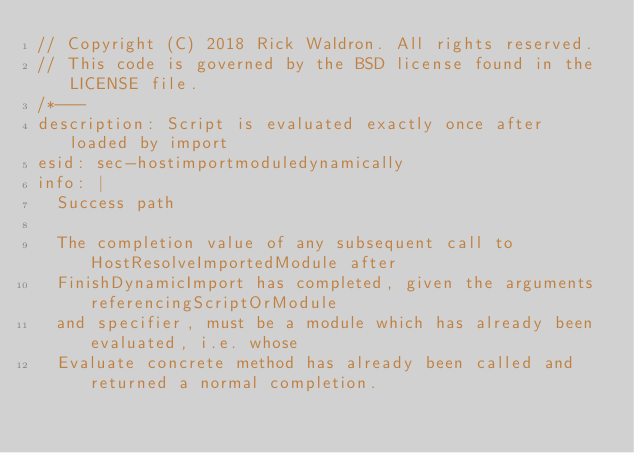Convert code to text. <code><loc_0><loc_0><loc_500><loc_500><_JavaScript_>// Copyright (C) 2018 Rick Waldron. All rights reserved.
// This code is governed by the BSD license found in the LICENSE file.
/*---
description: Script is evaluated exactly once after loaded by import
esid: sec-hostimportmoduledynamically
info: |
  Success path

  The completion value of any subsequent call to HostResolveImportedModule after
  FinishDynamicImport has completed, given the arguments referencingScriptOrModule
  and specifier, must be a module which has already been evaluated, i.e. whose
  Evaluate concrete method has already been called and returned a normal completion.
</code> 